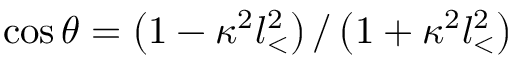<formula> <loc_0><loc_0><loc_500><loc_500>\cos \theta = \left ( 1 - \kappa ^ { 2 } l _ { < } ^ { 2 } \right ) / \left ( 1 + \kappa ^ { 2 } l _ { < } ^ { 2 } \right )</formula> 